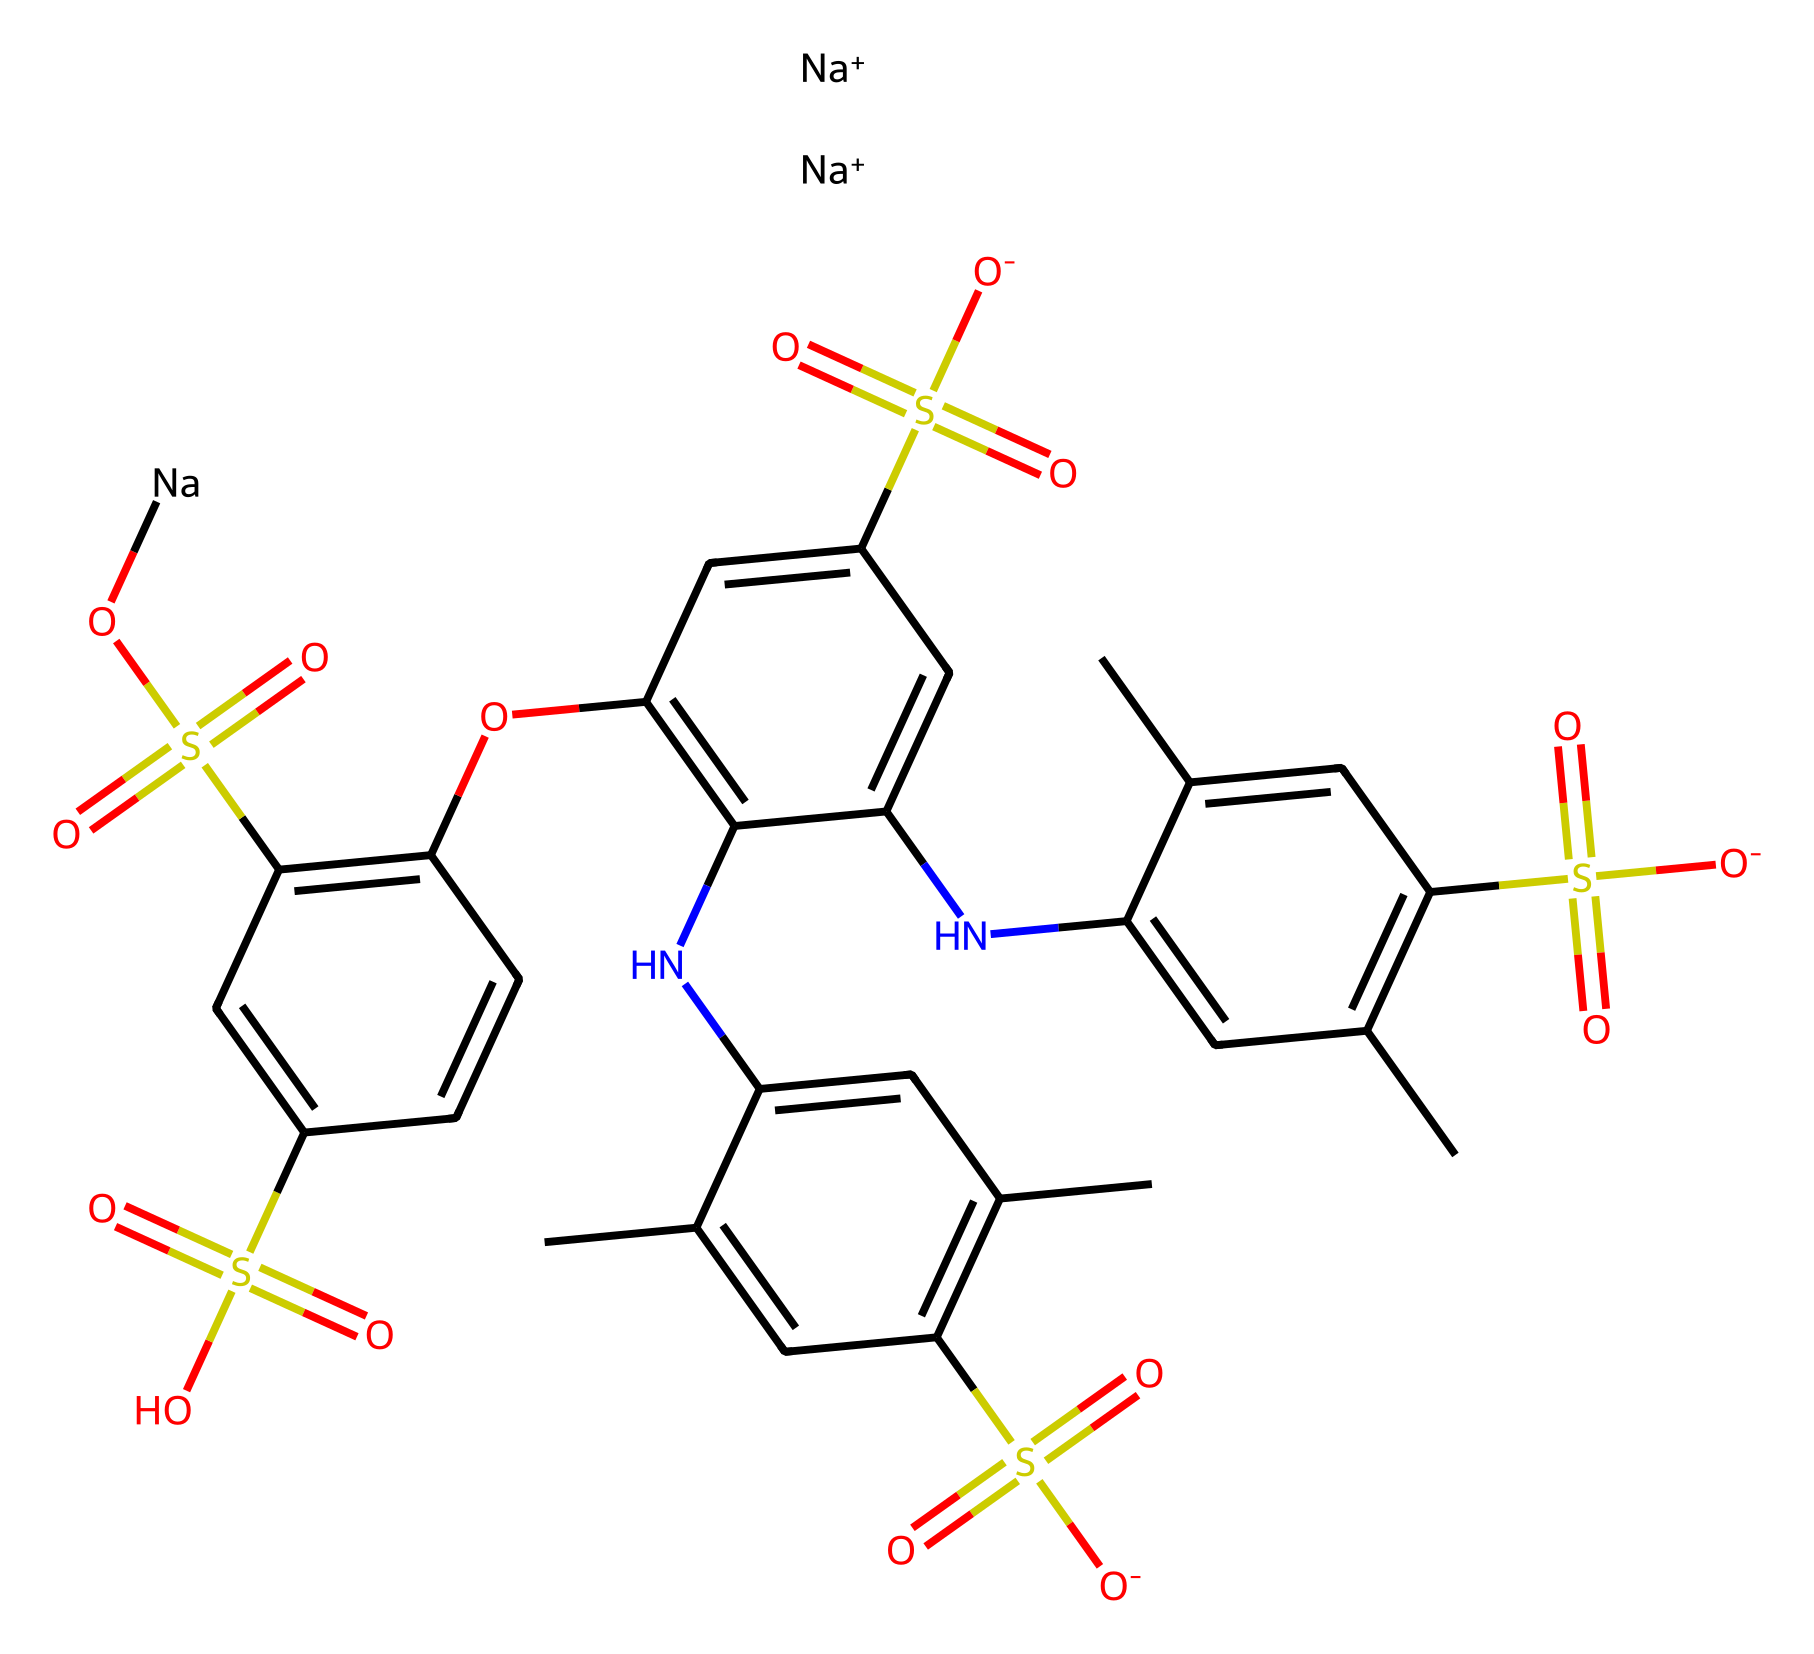What is the name of this chemical? The SMILES representation indicates that this compound is known as Brilliant Blue FCF, which is commonly used as a dye.
Answer: Brilliant Blue FCF How many sodium atoms are present in the structure? The SMILES notation shows two occurrences of [Na+], indicating there are two sodium atoms in the structure.
Answer: 2 What type of compound is Brilliant Blue FCF? Brilliant Blue FCF is classified as a synthetic dye used primarily for coloring food and beverages. The presence of sulfonic acid groups suggests its use as an anionic dye.
Answer: synthetic dye What functional groups are present in this compound? The SMILES notation depicts sulfonic acid groups (–SO3H), a phenolic hydroxyl group (–OH), and amine groups (–NH) within the structure.
Answer: sulfonic acid groups, phenolic hydroxyl group, amine groups What color does Brilliant Blue FCF impart to sports drinks? As suggested by its name, Brilliant Blue FCF imparts a blue color to the products it is added to, which is characteristic of the dye.
Answer: blue 